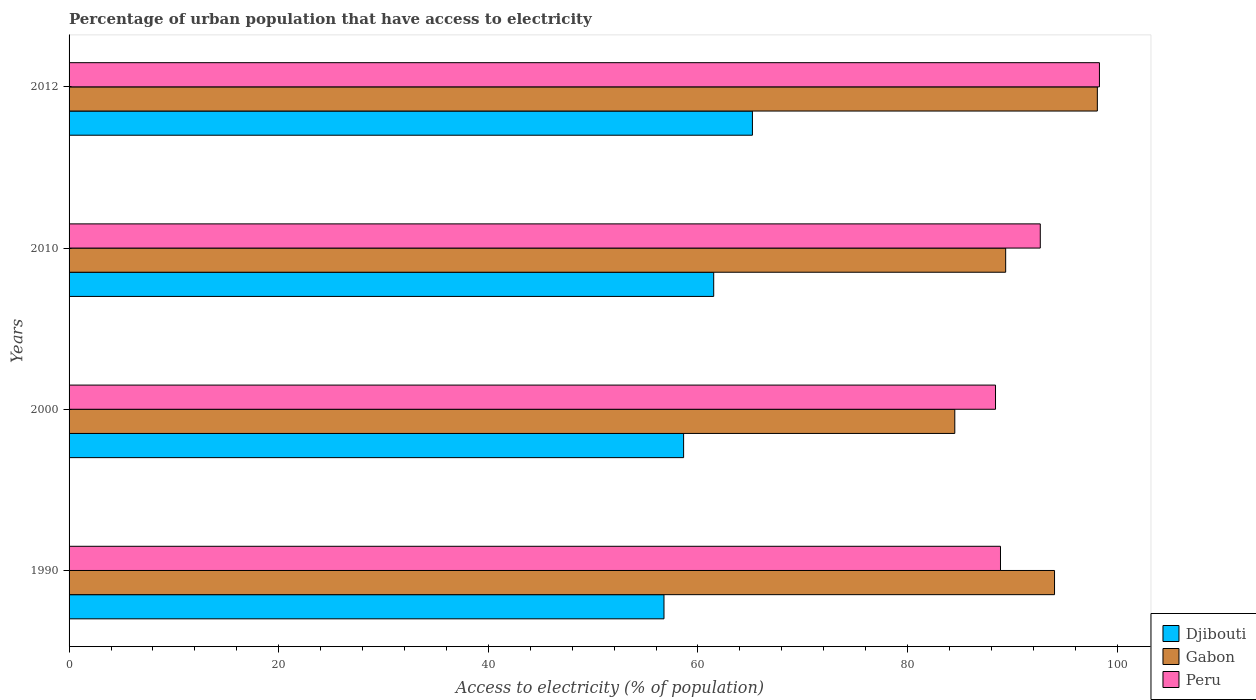How many bars are there on the 3rd tick from the bottom?
Your answer should be compact. 3. In how many cases, is the number of bars for a given year not equal to the number of legend labels?
Provide a short and direct response. 0. What is the percentage of urban population that have access to electricity in Peru in 2010?
Ensure brevity in your answer.  92.66. Across all years, what is the maximum percentage of urban population that have access to electricity in Peru?
Ensure brevity in your answer.  98.3. Across all years, what is the minimum percentage of urban population that have access to electricity in Peru?
Provide a short and direct response. 88.39. In which year was the percentage of urban population that have access to electricity in Peru maximum?
Your answer should be compact. 2012. In which year was the percentage of urban population that have access to electricity in Peru minimum?
Offer a very short reply. 2000. What is the total percentage of urban population that have access to electricity in Djibouti in the graph?
Provide a short and direct response. 242.08. What is the difference between the percentage of urban population that have access to electricity in Peru in 1990 and that in 2000?
Provide a succinct answer. 0.47. What is the difference between the percentage of urban population that have access to electricity in Peru in 2000 and the percentage of urban population that have access to electricity in Gabon in 2012?
Your response must be concise. -9.71. What is the average percentage of urban population that have access to electricity in Djibouti per year?
Give a very brief answer. 60.52. In the year 2010, what is the difference between the percentage of urban population that have access to electricity in Djibouti and percentage of urban population that have access to electricity in Peru?
Make the answer very short. -31.16. In how many years, is the percentage of urban population that have access to electricity in Gabon greater than 64 %?
Provide a succinct answer. 4. What is the ratio of the percentage of urban population that have access to electricity in Djibouti in 1990 to that in 2010?
Offer a very short reply. 0.92. What is the difference between the highest and the second highest percentage of urban population that have access to electricity in Djibouti?
Provide a succinct answer. 3.69. What is the difference between the highest and the lowest percentage of urban population that have access to electricity in Gabon?
Ensure brevity in your answer.  13.6. In how many years, is the percentage of urban population that have access to electricity in Djibouti greater than the average percentage of urban population that have access to electricity in Djibouti taken over all years?
Your answer should be compact. 2. Is the sum of the percentage of urban population that have access to electricity in Peru in 2010 and 2012 greater than the maximum percentage of urban population that have access to electricity in Djibouti across all years?
Provide a short and direct response. Yes. What does the 2nd bar from the top in 2000 represents?
Keep it short and to the point. Gabon. What does the 1st bar from the bottom in 1990 represents?
Your answer should be very brief. Djibouti. Are all the bars in the graph horizontal?
Your response must be concise. Yes. Does the graph contain grids?
Provide a succinct answer. No. How many legend labels are there?
Your response must be concise. 3. How are the legend labels stacked?
Your answer should be very brief. Vertical. What is the title of the graph?
Keep it short and to the point. Percentage of urban population that have access to electricity. What is the label or title of the X-axis?
Your response must be concise. Access to electricity (% of population). What is the Access to electricity (% of population) of Djibouti in 1990?
Make the answer very short. 56.76. What is the Access to electricity (% of population) of Gabon in 1990?
Make the answer very short. 94.02. What is the Access to electricity (% of population) in Peru in 1990?
Your answer should be compact. 88.86. What is the Access to electricity (% of population) in Djibouti in 2000?
Give a very brief answer. 58.63. What is the Access to electricity (% of population) in Gabon in 2000?
Provide a succinct answer. 84.5. What is the Access to electricity (% of population) in Peru in 2000?
Offer a terse response. 88.39. What is the Access to electricity (% of population) of Djibouti in 2010?
Give a very brief answer. 61.5. What is the Access to electricity (% of population) of Gabon in 2010?
Your answer should be very brief. 89.35. What is the Access to electricity (% of population) of Peru in 2010?
Provide a short and direct response. 92.66. What is the Access to electricity (% of population) of Djibouti in 2012?
Provide a succinct answer. 65.19. What is the Access to electricity (% of population) in Gabon in 2012?
Your response must be concise. 98.1. What is the Access to electricity (% of population) in Peru in 2012?
Your answer should be compact. 98.3. Across all years, what is the maximum Access to electricity (% of population) of Djibouti?
Make the answer very short. 65.19. Across all years, what is the maximum Access to electricity (% of population) in Gabon?
Offer a very short reply. 98.1. Across all years, what is the maximum Access to electricity (% of population) in Peru?
Ensure brevity in your answer.  98.3. Across all years, what is the minimum Access to electricity (% of population) of Djibouti?
Offer a terse response. 56.76. Across all years, what is the minimum Access to electricity (% of population) in Gabon?
Provide a short and direct response. 84.5. Across all years, what is the minimum Access to electricity (% of population) in Peru?
Give a very brief answer. 88.39. What is the total Access to electricity (% of population) in Djibouti in the graph?
Offer a very short reply. 242.08. What is the total Access to electricity (% of population) of Gabon in the graph?
Your answer should be very brief. 365.97. What is the total Access to electricity (% of population) of Peru in the graph?
Provide a short and direct response. 368.2. What is the difference between the Access to electricity (% of population) of Djibouti in 1990 and that in 2000?
Make the answer very short. -1.87. What is the difference between the Access to electricity (% of population) of Gabon in 1990 and that in 2000?
Your answer should be very brief. 9.51. What is the difference between the Access to electricity (% of population) of Peru in 1990 and that in 2000?
Offer a terse response. 0.47. What is the difference between the Access to electricity (% of population) of Djibouti in 1990 and that in 2010?
Make the answer very short. -4.74. What is the difference between the Access to electricity (% of population) of Gabon in 1990 and that in 2010?
Ensure brevity in your answer.  4.66. What is the difference between the Access to electricity (% of population) in Peru in 1990 and that in 2010?
Ensure brevity in your answer.  -3.8. What is the difference between the Access to electricity (% of population) of Djibouti in 1990 and that in 2012?
Make the answer very short. -8.44. What is the difference between the Access to electricity (% of population) of Gabon in 1990 and that in 2012?
Provide a succinct answer. -4.08. What is the difference between the Access to electricity (% of population) of Peru in 1990 and that in 2012?
Your response must be concise. -9.44. What is the difference between the Access to electricity (% of population) in Djibouti in 2000 and that in 2010?
Your response must be concise. -2.87. What is the difference between the Access to electricity (% of population) of Gabon in 2000 and that in 2010?
Give a very brief answer. -4.85. What is the difference between the Access to electricity (% of population) in Peru in 2000 and that in 2010?
Provide a succinct answer. -4.27. What is the difference between the Access to electricity (% of population) of Djibouti in 2000 and that in 2012?
Keep it short and to the point. -6.56. What is the difference between the Access to electricity (% of population) in Gabon in 2000 and that in 2012?
Keep it short and to the point. -13.6. What is the difference between the Access to electricity (% of population) in Peru in 2000 and that in 2012?
Your answer should be very brief. -9.91. What is the difference between the Access to electricity (% of population) in Djibouti in 2010 and that in 2012?
Keep it short and to the point. -3.69. What is the difference between the Access to electricity (% of population) of Gabon in 2010 and that in 2012?
Ensure brevity in your answer.  -8.75. What is the difference between the Access to electricity (% of population) of Peru in 2010 and that in 2012?
Your answer should be very brief. -5.64. What is the difference between the Access to electricity (% of population) in Djibouti in 1990 and the Access to electricity (% of population) in Gabon in 2000?
Your answer should be compact. -27.75. What is the difference between the Access to electricity (% of population) in Djibouti in 1990 and the Access to electricity (% of population) in Peru in 2000?
Offer a very short reply. -31.63. What is the difference between the Access to electricity (% of population) of Gabon in 1990 and the Access to electricity (% of population) of Peru in 2000?
Give a very brief answer. 5.63. What is the difference between the Access to electricity (% of population) of Djibouti in 1990 and the Access to electricity (% of population) of Gabon in 2010?
Provide a short and direct response. -32.6. What is the difference between the Access to electricity (% of population) in Djibouti in 1990 and the Access to electricity (% of population) in Peru in 2010?
Your response must be concise. -35.9. What is the difference between the Access to electricity (% of population) in Gabon in 1990 and the Access to electricity (% of population) in Peru in 2010?
Offer a very short reply. 1.36. What is the difference between the Access to electricity (% of population) in Djibouti in 1990 and the Access to electricity (% of population) in Gabon in 2012?
Ensure brevity in your answer.  -41.34. What is the difference between the Access to electricity (% of population) of Djibouti in 1990 and the Access to electricity (% of population) of Peru in 2012?
Provide a short and direct response. -41.54. What is the difference between the Access to electricity (% of population) in Gabon in 1990 and the Access to electricity (% of population) in Peru in 2012?
Your response must be concise. -4.28. What is the difference between the Access to electricity (% of population) of Djibouti in 2000 and the Access to electricity (% of population) of Gabon in 2010?
Provide a short and direct response. -30.73. What is the difference between the Access to electricity (% of population) of Djibouti in 2000 and the Access to electricity (% of population) of Peru in 2010?
Provide a succinct answer. -34.03. What is the difference between the Access to electricity (% of population) of Gabon in 2000 and the Access to electricity (% of population) of Peru in 2010?
Keep it short and to the point. -8.15. What is the difference between the Access to electricity (% of population) of Djibouti in 2000 and the Access to electricity (% of population) of Gabon in 2012?
Your answer should be compact. -39.47. What is the difference between the Access to electricity (% of population) in Djibouti in 2000 and the Access to electricity (% of population) in Peru in 2012?
Provide a succinct answer. -39.67. What is the difference between the Access to electricity (% of population) of Gabon in 2000 and the Access to electricity (% of population) of Peru in 2012?
Your answer should be compact. -13.8. What is the difference between the Access to electricity (% of population) in Djibouti in 2010 and the Access to electricity (% of population) in Gabon in 2012?
Provide a short and direct response. -36.6. What is the difference between the Access to electricity (% of population) in Djibouti in 2010 and the Access to electricity (% of population) in Peru in 2012?
Provide a succinct answer. -36.8. What is the difference between the Access to electricity (% of population) in Gabon in 2010 and the Access to electricity (% of population) in Peru in 2012?
Give a very brief answer. -8.95. What is the average Access to electricity (% of population) in Djibouti per year?
Give a very brief answer. 60.52. What is the average Access to electricity (% of population) of Gabon per year?
Your answer should be very brief. 91.49. What is the average Access to electricity (% of population) of Peru per year?
Provide a succinct answer. 92.05. In the year 1990, what is the difference between the Access to electricity (% of population) in Djibouti and Access to electricity (% of population) in Gabon?
Keep it short and to the point. -37.26. In the year 1990, what is the difference between the Access to electricity (% of population) in Djibouti and Access to electricity (% of population) in Peru?
Offer a very short reply. -32.1. In the year 1990, what is the difference between the Access to electricity (% of population) of Gabon and Access to electricity (% of population) of Peru?
Give a very brief answer. 5.16. In the year 2000, what is the difference between the Access to electricity (% of population) of Djibouti and Access to electricity (% of population) of Gabon?
Ensure brevity in your answer.  -25.87. In the year 2000, what is the difference between the Access to electricity (% of population) of Djibouti and Access to electricity (% of population) of Peru?
Ensure brevity in your answer.  -29.76. In the year 2000, what is the difference between the Access to electricity (% of population) in Gabon and Access to electricity (% of population) in Peru?
Ensure brevity in your answer.  -3.88. In the year 2010, what is the difference between the Access to electricity (% of population) of Djibouti and Access to electricity (% of population) of Gabon?
Keep it short and to the point. -27.85. In the year 2010, what is the difference between the Access to electricity (% of population) in Djibouti and Access to electricity (% of population) in Peru?
Offer a terse response. -31.16. In the year 2010, what is the difference between the Access to electricity (% of population) in Gabon and Access to electricity (% of population) in Peru?
Offer a terse response. -3.3. In the year 2012, what is the difference between the Access to electricity (% of population) of Djibouti and Access to electricity (% of population) of Gabon?
Provide a succinct answer. -32.91. In the year 2012, what is the difference between the Access to electricity (% of population) in Djibouti and Access to electricity (% of population) in Peru?
Provide a short and direct response. -33.11. In the year 2012, what is the difference between the Access to electricity (% of population) in Gabon and Access to electricity (% of population) in Peru?
Provide a succinct answer. -0.2. What is the ratio of the Access to electricity (% of population) in Djibouti in 1990 to that in 2000?
Give a very brief answer. 0.97. What is the ratio of the Access to electricity (% of population) of Gabon in 1990 to that in 2000?
Your answer should be compact. 1.11. What is the ratio of the Access to electricity (% of population) of Peru in 1990 to that in 2000?
Your answer should be very brief. 1.01. What is the ratio of the Access to electricity (% of population) of Djibouti in 1990 to that in 2010?
Make the answer very short. 0.92. What is the ratio of the Access to electricity (% of population) in Gabon in 1990 to that in 2010?
Keep it short and to the point. 1.05. What is the ratio of the Access to electricity (% of population) in Peru in 1990 to that in 2010?
Offer a terse response. 0.96. What is the ratio of the Access to electricity (% of population) in Djibouti in 1990 to that in 2012?
Offer a terse response. 0.87. What is the ratio of the Access to electricity (% of population) in Gabon in 1990 to that in 2012?
Offer a terse response. 0.96. What is the ratio of the Access to electricity (% of population) in Peru in 1990 to that in 2012?
Make the answer very short. 0.9. What is the ratio of the Access to electricity (% of population) of Djibouti in 2000 to that in 2010?
Your answer should be very brief. 0.95. What is the ratio of the Access to electricity (% of population) in Gabon in 2000 to that in 2010?
Offer a terse response. 0.95. What is the ratio of the Access to electricity (% of population) in Peru in 2000 to that in 2010?
Ensure brevity in your answer.  0.95. What is the ratio of the Access to electricity (% of population) of Djibouti in 2000 to that in 2012?
Your answer should be compact. 0.9. What is the ratio of the Access to electricity (% of population) of Gabon in 2000 to that in 2012?
Make the answer very short. 0.86. What is the ratio of the Access to electricity (% of population) of Peru in 2000 to that in 2012?
Offer a terse response. 0.9. What is the ratio of the Access to electricity (% of population) of Djibouti in 2010 to that in 2012?
Ensure brevity in your answer.  0.94. What is the ratio of the Access to electricity (% of population) of Gabon in 2010 to that in 2012?
Make the answer very short. 0.91. What is the ratio of the Access to electricity (% of population) of Peru in 2010 to that in 2012?
Give a very brief answer. 0.94. What is the difference between the highest and the second highest Access to electricity (% of population) of Djibouti?
Your answer should be compact. 3.69. What is the difference between the highest and the second highest Access to electricity (% of population) in Gabon?
Offer a terse response. 4.08. What is the difference between the highest and the second highest Access to electricity (% of population) in Peru?
Keep it short and to the point. 5.64. What is the difference between the highest and the lowest Access to electricity (% of population) in Djibouti?
Provide a succinct answer. 8.44. What is the difference between the highest and the lowest Access to electricity (% of population) in Gabon?
Provide a succinct answer. 13.6. What is the difference between the highest and the lowest Access to electricity (% of population) in Peru?
Ensure brevity in your answer.  9.91. 